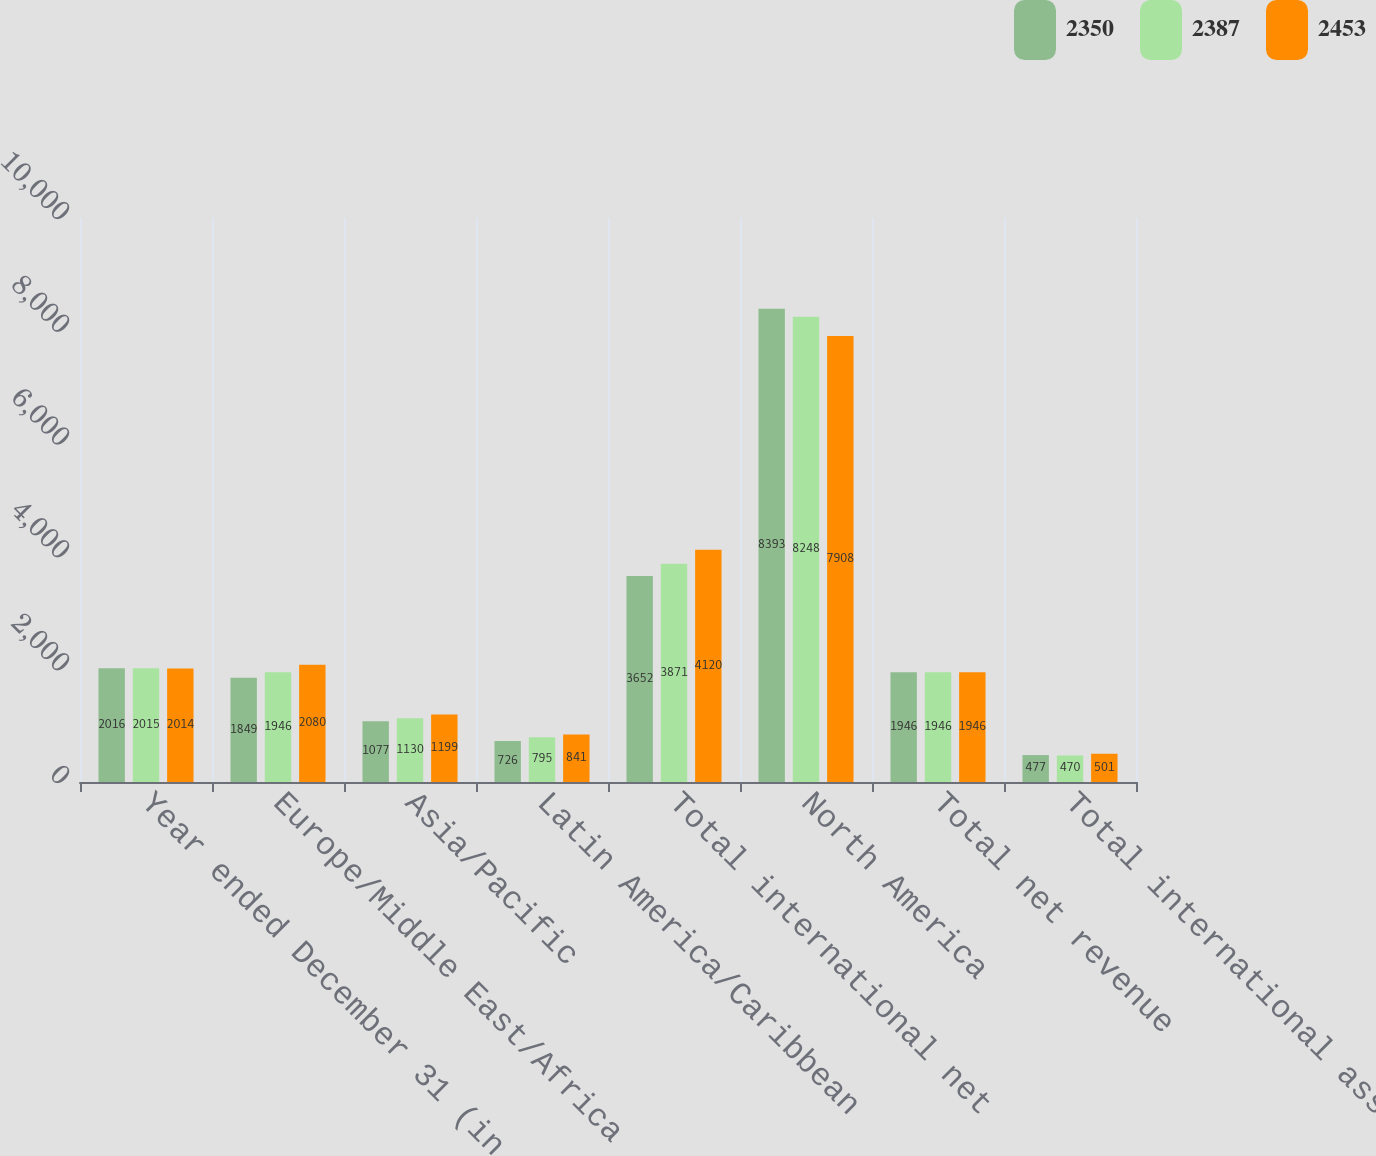Convert chart to OTSL. <chart><loc_0><loc_0><loc_500><loc_500><stacked_bar_chart><ecel><fcel>Year ended December 31 (in<fcel>Europe/Middle East/Africa<fcel>Asia/Pacific<fcel>Latin America/Caribbean<fcel>Total international net<fcel>North America<fcel>Total net revenue<fcel>Total international assets<nl><fcel>2350<fcel>2016<fcel>1849<fcel>1077<fcel>726<fcel>3652<fcel>8393<fcel>1946<fcel>477<nl><fcel>2387<fcel>2015<fcel>1946<fcel>1130<fcel>795<fcel>3871<fcel>8248<fcel>1946<fcel>470<nl><fcel>2453<fcel>2014<fcel>2080<fcel>1199<fcel>841<fcel>4120<fcel>7908<fcel>1946<fcel>501<nl></chart> 